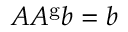Convert formula to latex. <formula><loc_0><loc_0><loc_500><loc_500>A A ^ { g } b = b</formula> 